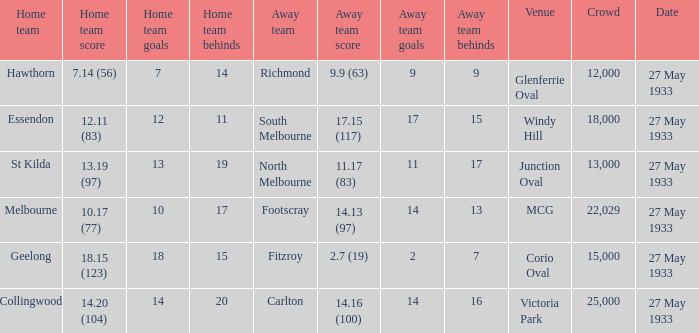In the match where the home team scored 14.20 (104), how many attendees were in the crowd? 25000.0. 